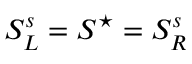Convert formula to latex. <formula><loc_0><loc_0><loc_500><loc_500>S _ { L } ^ { s } = S ^ { ^ { * } } = S _ { R } ^ { s }</formula> 